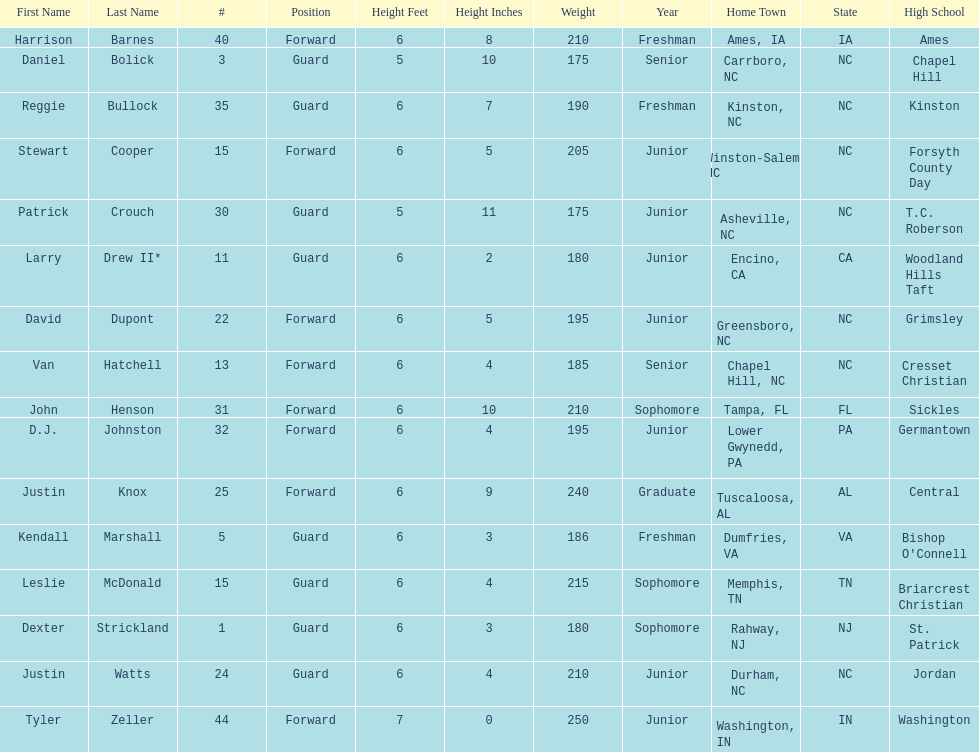How many players were taller than van hatchell? 7. 